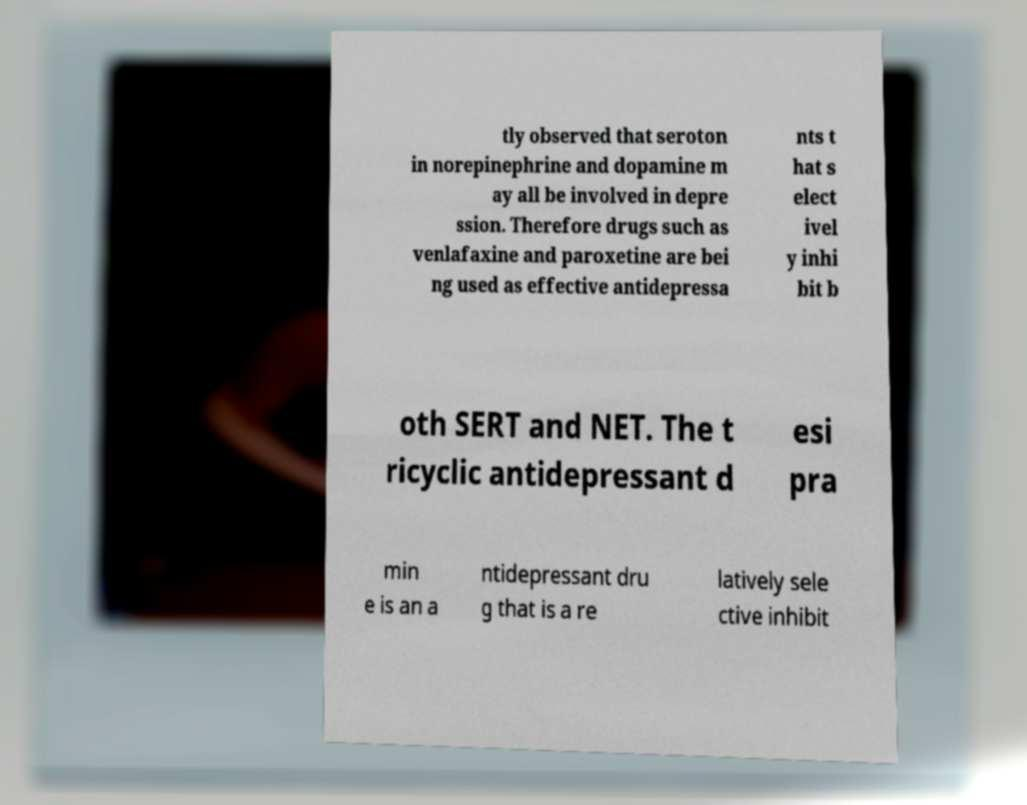What messages or text are displayed in this image? I need them in a readable, typed format. tly observed that seroton in norepinephrine and dopamine m ay all be involved in depre ssion. Therefore drugs such as venlafaxine and paroxetine are bei ng used as effective antidepressa nts t hat s elect ivel y inhi bit b oth SERT and NET. The t ricyclic antidepressant d esi pra min e is an a ntidepressant dru g that is a re latively sele ctive inhibit 